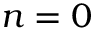Convert formula to latex. <formula><loc_0><loc_0><loc_500><loc_500>n = 0</formula> 